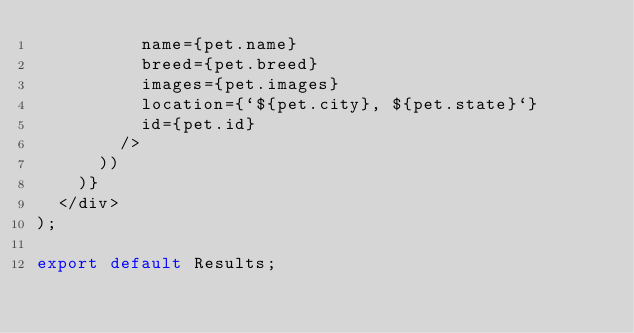Convert code to text. <code><loc_0><loc_0><loc_500><loc_500><_JavaScript_>          name={pet.name}
          breed={pet.breed}
          images={pet.images}
          location={`${pet.city}, ${pet.state}`}
          id={pet.id}
        />
      ))
    )}
  </div>
);

export default Results;
</code> 